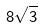Convert formula to latex. <formula><loc_0><loc_0><loc_500><loc_500>8 \sqrt { 3 }</formula> 